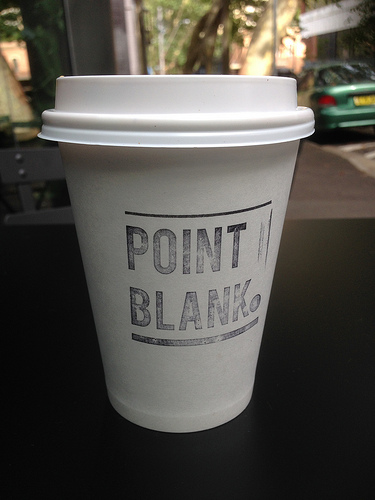<image>
Can you confirm if the tree is behind the cup? Yes. From this viewpoint, the tree is positioned behind the cup, with the cup partially or fully occluding the tree. 